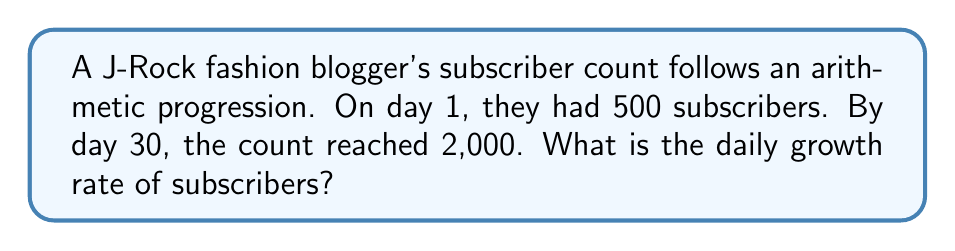Teach me how to tackle this problem. Let's approach this step-by-step:

1) In an arithmetic progression, the difference between each term is constant. Let's call this common difference $d$.

2) We know:
   - Initial term (a₁) = 500 subscribers
   - 30th term (a₃₀) = 2,000 subscribers

3) The formula for the nth term of an arithmetic sequence is:
   $a_n = a_1 + (n-1)d$

4) Substituting our known values:
   $2000 = 500 + (30-1)d$
   $2000 = 500 + 29d$

5) Solve for $d$:
   $1500 = 29d$
   $d = \frac{1500}{29} \approx 51.72$

6) This means the blog gains approximately 51.72 subscribers per day.

7) To calculate the daily growth rate as a percentage:
   $\text{Daily Growth Rate} = \frac{\text{Daily Increase}}{\text{Initial Value}} \times 100\%$

   $= \frac{51.72}{500} \times 100\% \approx 10.34\%$
Answer: $10.34\%$ 